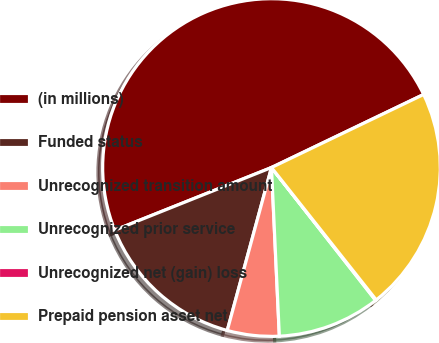Convert chart. <chart><loc_0><loc_0><loc_500><loc_500><pie_chart><fcel>(in millions)<fcel>Funded status<fcel>Unrecognized transition amount<fcel>Unrecognized prior service<fcel>Unrecognized net (gain) loss<fcel>Prepaid pension asset net<nl><fcel>48.92%<fcel>14.73%<fcel>4.96%<fcel>9.84%<fcel>0.07%<fcel>21.47%<nl></chart> 